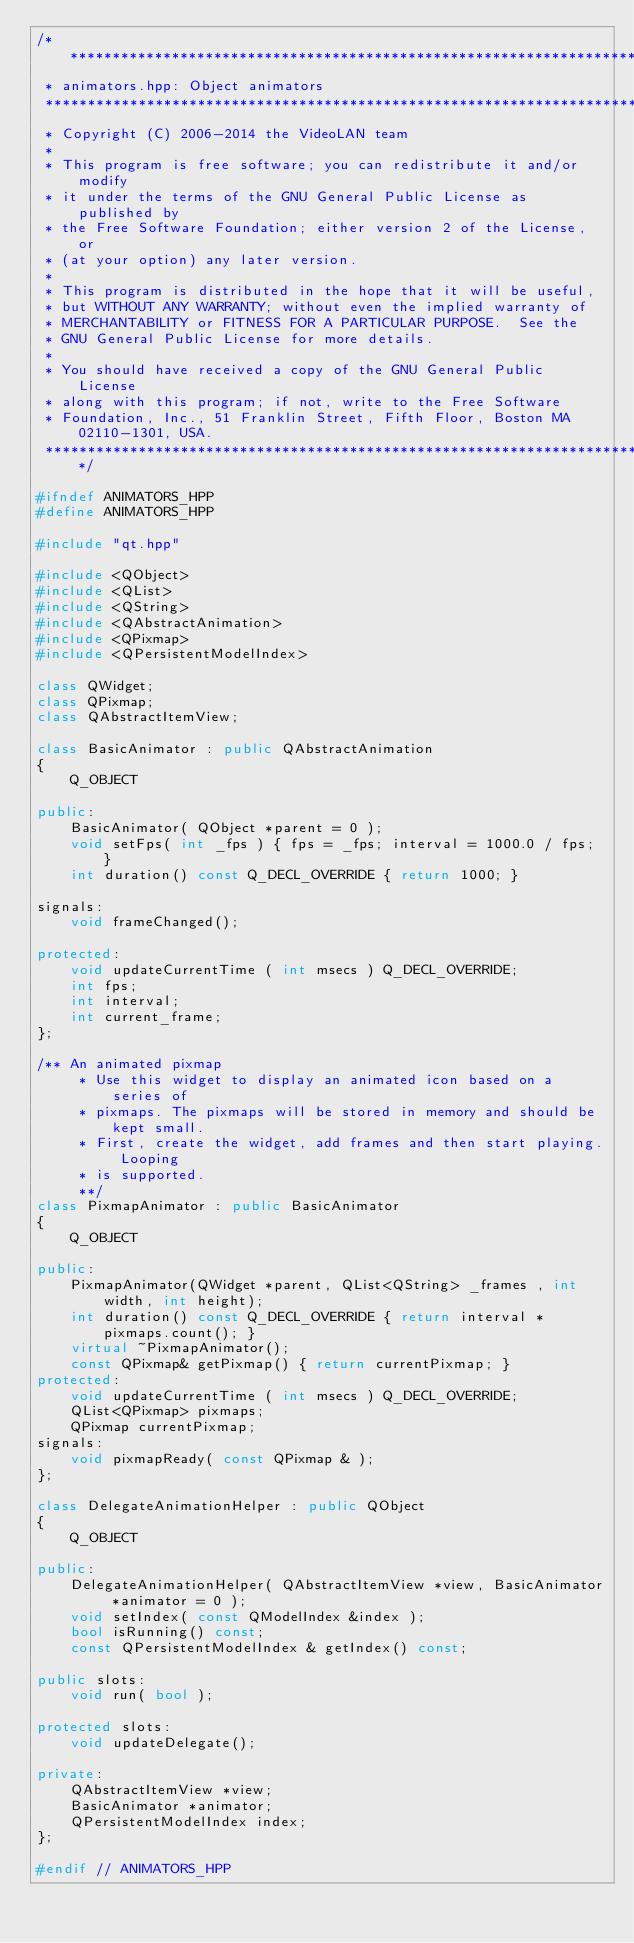Convert code to text. <code><loc_0><loc_0><loc_500><loc_500><_C++_>/*****************************************************************************
 * animators.hpp: Object animators
 ****************************************************************************
 * Copyright (C) 2006-2014 the VideoLAN team
 *
 * This program is free software; you can redistribute it and/or modify
 * it under the terms of the GNU General Public License as published by
 * the Free Software Foundation; either version 2 of the License, or
 * (at your option) any later version.
 *
 * This program is distributed in the hope that it will be useful,
 * but WITHOUT ANY WARRANTY; without even the implied warranty of
 * MERCHANTABILITY or FITNESS FOR A PARTICULAR PURPOSE.  See the
 * GNU General Public License for more details.
 *
 * You should have received a copy of the GNU General Public License
 * along with this program; if not, write to the Free Software
 * Foundation, Inc., 51 Franklin Street, Fifth Floor, Boston MA 02110-1301, USA.
 *****************************************************************************/

#ifndef ANIMATORS_HPP
#define ANIMATORS_HPP

#include "qt.hpp"

#include <QObject>
#include <QList>
#include <QString>
#include <QAbstractAnimation>
#include <QPixmap>
#include <QPersistentModelIndex>

class QWidget;
class QPixmap;
class QAbstractItemView;

class BasicAnimator : public QAbstractAnimation
{
    Q_OBJECT

public:
    BasicAnimator( QObject *parent = 0 );
    void setFps( int _fps ) { fps = _fps; interval = 1000.0 / fps; }
    int duration() const Q_DECL_OVERRIDE { return 1000; }

signals:
    void frameChanged();

protected:
    void updateCurrentTime ( int msecs ) Q_DECL_OVERRIDE;
    int fps;
    int interval;
    int current_frame;
};

/** An animated pixmap
     * Use this widget to display an animated icon based on a series of
     * pixmaps. The pixmaps will be stored in memory and should be kept small.
     * First, create the widget, add frames and then start playing. Looping
     * is supported.
     **/
class PixmapAnimator : public BasicAnimator
{
    Q_OBJECT

public:
    PixmapAnimator(QWidget *parent, QList<QString> _frames , int width, int height);
    int duration() const Q_DECL_OVERRIDE { return interval * pixmaps.count(); }
    virtual ~PixmapAnimator();
    const QPixmap& getPixmap() { return currentPixmap; }
protected:
    void updateCurrentTime ( int msecs ) Q_DECL_OVERRIDE;
    QList<QPixmap> pixmaps;
    QPixmap currentPixmap;
signals:
    void pixmapReady( const QPixmap & );
};

class DelegateAnimationHelper : public QObject
{
    Q_OBJECT

public:
    DelegateAnimationHelper( QAbstractItemView *view, BasicAnimator *animator = 0 );
    void setIndex( const QModelIndex &index );
    bool isRunning() const;
    const QPersistentModelIndex & getIndex() const;

public slots:
    void run( bool );

protected slots:
    void updateDelegate();

private:
    QAbstractItemView *view;
    BasicAnimator *animator;
    QPersistentModelIndex index;
};

#endif // ANIMATORS_HPP
</code> 